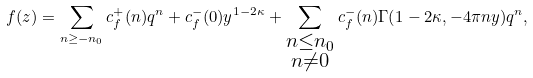Convert formula to latex. <formula><loc_0><loc_0><loc_500><loc_500>f ( z ) = \sum _ { n \geq - n _ { 0 } } c _ { f } ^ { + } ( n ) q ^ { n } + c _ { f } ^ { - } ( 0 ) y ^ { 1 - 2 \kappa } + \sum _ { \substack { n \leq n _ { 0 } \\ n \neq 0 } } c _ { f } ^ { - } ( n ) \Gamma ( 1 - 2 \kappa , - 4 \pi n y ) q ^ { n } ,</formula> 